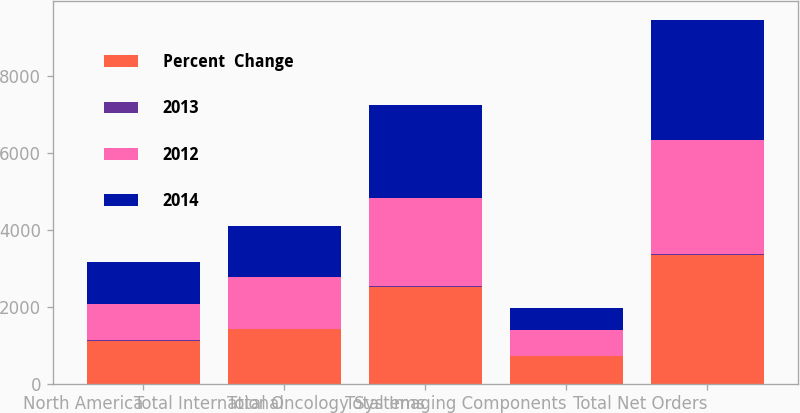Convert chart. <chart><loc_0><loc_0><loc_500><loc_500><stacked_bar_chart><ecel><fcel>North America<fcel>Total International<fcel>Total Oncology Systems<fcel>Total Imaging Components<fcel>Total Net Orders<nl><fcel>Percent  Change<fcel>1109.5<fcel>1411.3<fcel>2520.8<fcel>710.7<fcel>3351<nl><fcel>2013<fcel>18<fcel>4<fcel>10<fcel>7<fcel>13<nl><fcel>2012<fcel>938.9<fcel>1360.1<fcel>2299<fcel>665.9<fcel>2967.5<nl><fcel>2014<fcel>1091.4<fcel>1308.7<fcel>2400.1<fcel>595.5<fcel>3121.9<nl></chart> 